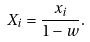<formula> <loc_0><loc_0><loc_500><loc_500>X _ { i } = \frac { x _ { i } } { 1 - w } .</formula> 